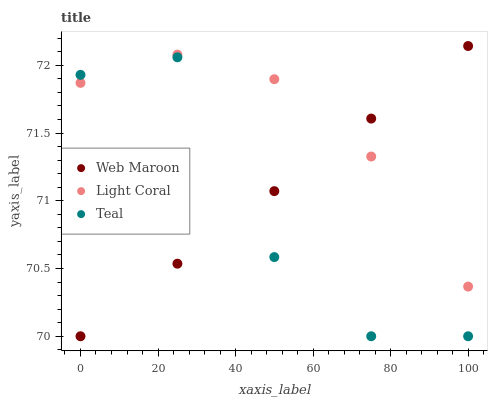Does Teal have the minimum area under the curve?
Answer yes or no. Yes. Does Light Coral have the maximum area under the curve?
Answer yes or no. Yes. Does Web Maroon have the minimum area under the curve?
Answer yes or no. No. Does Web Maroon have the maximum area under the curve?
Answer yes or no. No. Is Web Maroon the smoothest?
Answer yes or no. Yes. Is Teal the roughest?
Answer yes or no. Yes. Is Teal the smoothest?
Answer yes or no. No. Is Web Maroon the roughest?
Answer yes or no. No. Does Web Maroon have the lowest value?
Answer yes or no. Yes. Does Web Maroon have the highest value?
Answer yes or no. Yes. Does Teal have the highest value?
Answer yes or no. No. Does Light Coral intersect Web Maroon?
Answer yes or no. Yes. Is Light Coral less than Web Maroon?
Answer yes or no. No. Is Light Coral greater than Web Maroon?
Answer yes or no. No. 